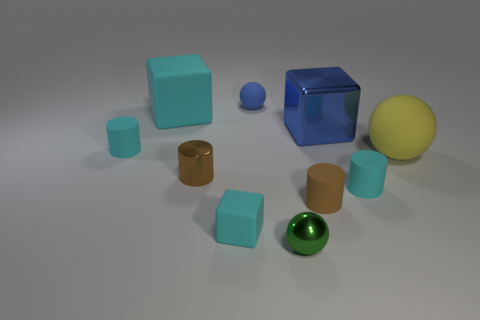How many brown objects have the same size as the yellow thing?
Your response must be concise. 0. Are there more big matte spheres to the left of the big metal block than large yellow rubber things left of the large rubber ball?
Offer a terse response. No. What is the material of the cyan object that is the same size as the yellow rubber ball?
Ensure brevity in your answer.  Rubber. What is the shape of the tiny brown rubber thing?
Your response must be concise. Cylinder. What number of purple things are cylinders or metal blocks?
Offer a terse response. 0. What size is the brown object that is the same material as the blue block?
Offer a terse response. Small. Is the small thing right of the large metal block made of the same material as the large object left of the brown metal cylinder?
Your response must be concise. Yes. What number of cubes are either tiny cyan matte things or blue metallic objects?
Your answer should be very brief. 2. What number of tiny cyan cylinders are in front of the big object that is in front of the matte cylinder that is on the left side of the blue ball?
Your response must be concise. 1. There is a blue object that is the same shape as the small green shiny thing; what material is it?
Your answer should be very brief. Rubber. 